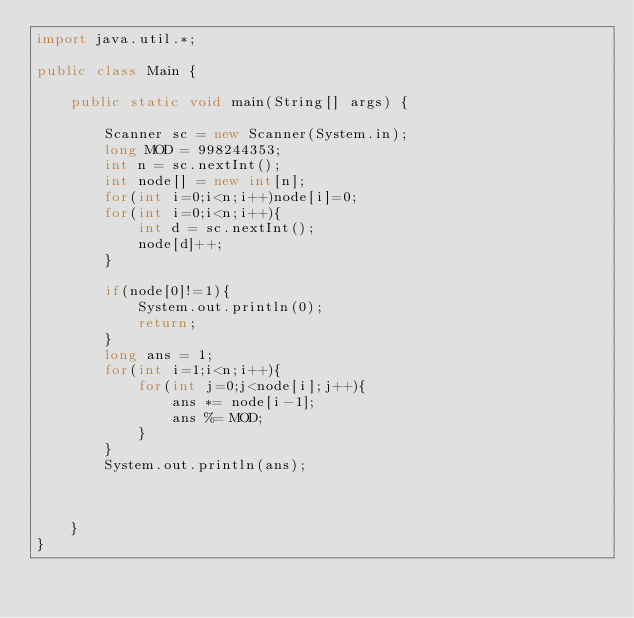Convert code to text. <code><loc_0><loc_0><loc_500><loc_500><_Java_>import java.util.*;

public class Main {

    public static void main(String[] args) {

        Scanner sc = new Scanner(System.in);
        long MOD = 998244353;
        int n = sc.nextInt();
        int node[] = new int[n];
        for(int i=0;i<n;i++)node[i]=0;
        for(int i=0;i<n;i++){
            int d = sc.nextInt();
            node[d]++;
        }

        if(node[0]!=1){
            System.out.println(0);
            return;
        }
        long ans = 1;
        for(int i=1;i<n;i++){
            for(int j=0;j<node[i];j++){
                ans *= node[i-1];
                ans %= MOD;
            }
        }
        System.out.println(ans);



    }
}
</code> 